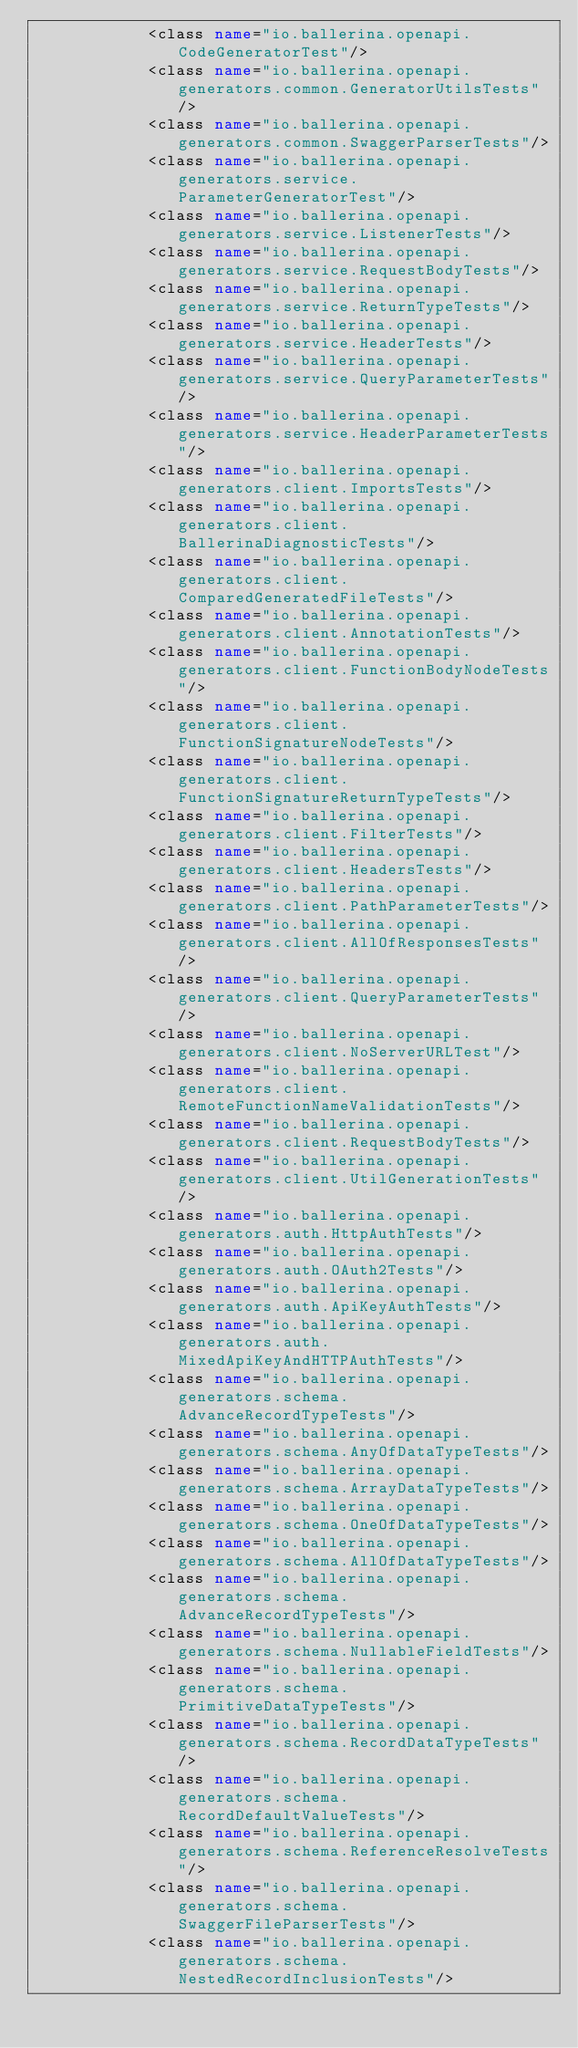<code> <loc_0><loc_0><loc_500><loc_500><_XML_>            <class name="io.ballerina.openapi.CodeGeneratorTest"/>
            <class name="io.ballerina.openapi.generators.common.GeneratorUtilsTests"/>
            <class name="io.ballerina.openapi.generators.common.SwaggerParserTests"/>
            <class name="io.ballerina.openapi.generators.service.ParameterGeneratorTest"/>
            <class name="io.ballerina.openapi.generators.service.ListenerTests"/>
            <class name="io.ballerina.openapi.generators.service.RequestBodyTests"/>
            <class name="io.ballerina.openapi.generators.service.ReturnTypeTests"/>
            <class name="io.ballerina.openapi.generators.service.HeaderTests"/>
            <class name="io.ballerina.openapi.generators.service.QueryParameterTests"/>
            <class name="io.ballerina.openapi.generators.service.HeaderParameterTests"/>
            <class name="io.ballerina.openapi.generators.client.ImportsTests"/>
            <class name="io.ballerina.openapi.generators.client.BallerinaDiagnosticTests"/>
            <class name="io.ballerina.openapi.generators.client.ComparedGeneratedFileTests"/>
            <class name="io.ballerina.openapi.generators.client.AnnotationTests"/>
            <class name="io.ballerina.openapi.generators.client.FunctionBodyNodeTests"/>
            <class name="io.ballerina.openapi.generators.client.FunctionSignatureNodeTests"/>
            <class name="io.ballerina.openapi.generators.client.FunctionSignatureReturnTypeTests"/>
            <class name="io.ballerina.openapi.generators.client.FilterTests"/>
            <class name="io.ballerina.openapi.generators.client.HeadersTests"/>
            <class name="io.ballerina.openapi.generators.client.PathParameterTests"/>
            <class name="io.ballerina.openapi.generators.client.AllOfResponsesTests"/>
            <class name="io.ballerina.openapi.generators.client.QueryParameterTests"/>
            <class name="io.ballerina.openapi.generators.client.NoServerURLTest"/>
            <class name="io.ballerina.openapi.generators.client.RemoteFunctionNameValidationTests"/>
            <class name="io.ballerina.openapi.generators.client.RequestBodyTests"/>
            <class name="io.ballerina.openapi.generators.client.UtilGenerationTests"/>
            <class name="io.ballerina.openapi.generators.auth.HttpAuthTests"/>
            <class name="io.ballerina.openapi.generators.auth.OAuth2Tests"/>
            <class name="io.ballerina.openapi.generators.auth.ApiKeyAuthTests"/>
            <class name="io.ballerina.openapi.generators.auth.MixedApiKeyAndHTTPAuthTests"/>
            <class name="io.ballerina.openapi.generators.schema.AdvanceRecordTypeTests"/>
            <class name="io.ballerina.openapi.generators.schema.AnyOfDataTypeTests"/>
            <class name="io.ballerina.openapi.generators.schema.ArrayDataTypeTests"/>
            <class name="io.ballerina.openapi.generators.schema.OneOfDataTypeTests"/>
            <class name="io.ballerina.openapi.generators.schema.AllOfDataTypeTests"/>
            <class name="io.ballerina.openapi.generators.schema.AdvanceRecordTypeTests"/>
            <class name="io.ballerina.openapi.generators.schema.NullableFieldTests"/>
            <class name="io.ballerina.openapi.generators.schema.PrimitiveDataTypeTests"/>
            <class name="io.ballerina.openapi.generators.schema.RecordDataTypeTests"/>
            <class name="io.ballerina.openapi.generators.schema.RecordDefaultValueTests"/>
            <class name="io.ballerina.openapi.generators.schema.ReferenceResolveTests"/>
            <class name="io.ballerina.openapi.generators.schema.SwaggerFileParserTests"/>
            <class name="io.ballerina.openapi.generators.schema.NestedRecordInclusionTests"/></code> 